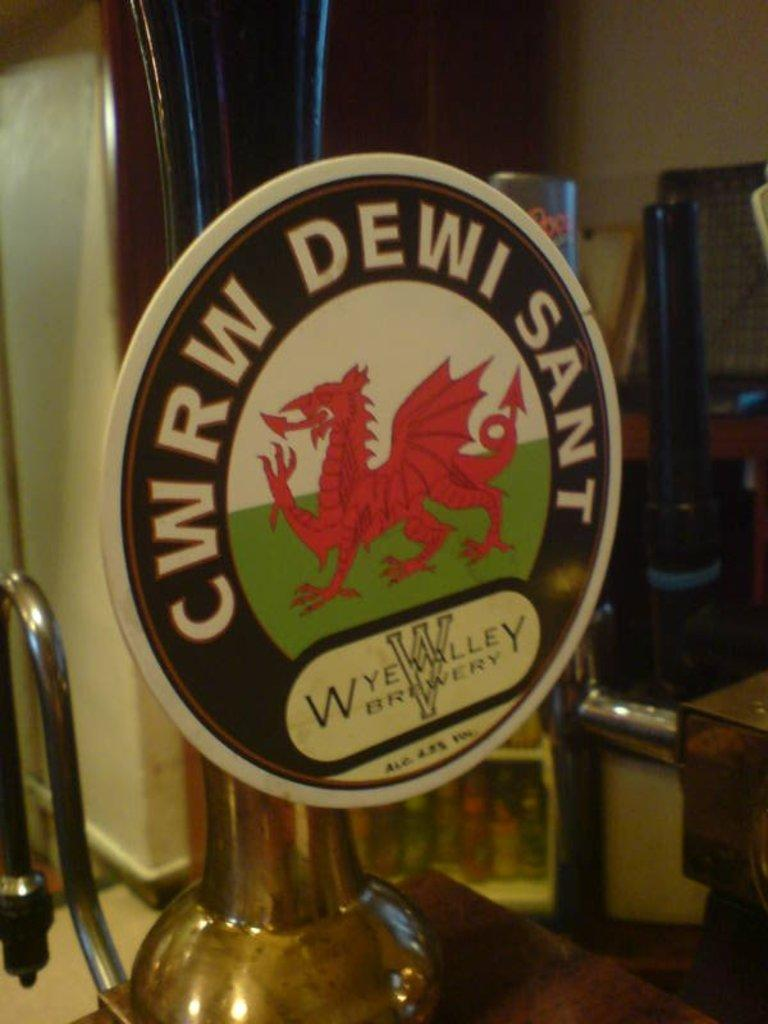<image>
Share a concise interpretation of the image provided. round logo for wye valley brewery that has red dragon in center 